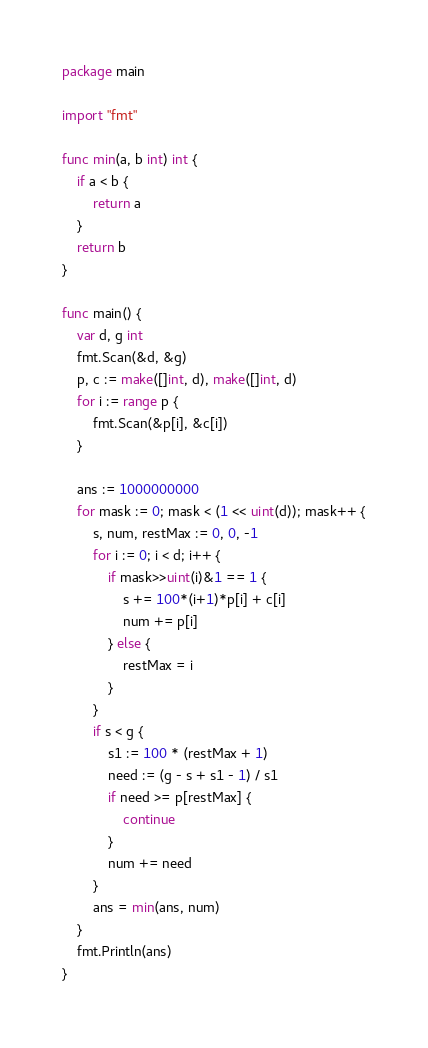<code> <loc_0><loc_0><loc_500><loc_500><_Go_>package main

import "fmt"

func min(a, b int) int {
	if a < b {
		return a
	}
	return b
}

func main() {
	var d, g int
	fmt.Scan(&d, &g)
	p, c := make([]int, d), make([]int, d)
	for i := range p {
		fmt.Scan(&p[i], &c[i])
	}

	ans := 1000000000
	for mask := 0; mask < (1 << uint(d)); mask++ {
		s, num, restMax := 0, 0, -1
		for i := 0; i < d; i++ {
			if mask>>uint(i)&1 == 1 {
				s += 100*(i+1)*p[i] + c[i]
				num += p[i]
			} else {
				restMax = i
			}
		}
		if s < g {
			s1 := 100 * (restMax + 1)
			need := (g - s + s1 - 1) / s1
			if need >= p[restMax] {
				continue
			}
			num += need
		}
		ans = min(ans, num)
	}
	fmt.Println(ans)
}
</code> 